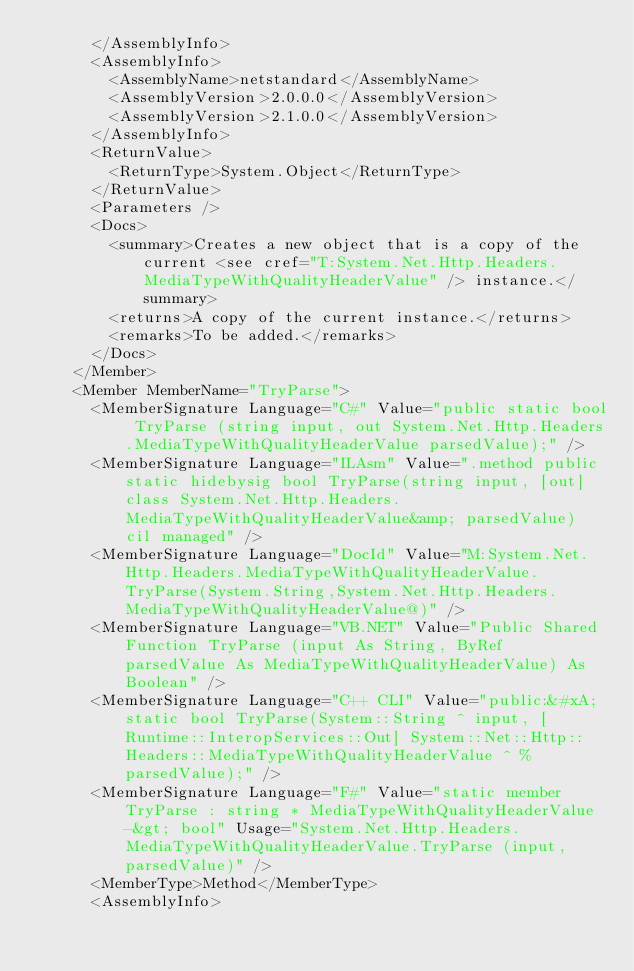Convert code to text. <code><loc_0><loc_0><loc_500><loc_500><_XML_>      </AssemblyInfo>
      <AssemblyInfo>
        <AssemblyName>netstandard</AssemblyName>
        <AssemblyVersion>2.0.0.0</AssemblyVersion>
        <AssemblyVersion>2.1.0.0</AssemblyVersion>
      </AssemblyInfo>
      <ReturnValue>
        <ReturnType>System.Object</ReturnType>
      </ReturnValue>
      <Parameters />
      <Docs>
        <summary>Creates a new object that is a copy of the current <see cref="T:System.Net.Http.Headers.MediaTypeWithQualityHeaderValue" /> instance.</summary>
        <returns>A copy of the current instance.</returns>
        <remarks>To be added.</remarks>
      </Docs>
    </Member>
    <Member MemberName="TryParse">
      <MemberSignature Language="C#" Value="public static bool TryParse (string input, out System.Net.Http.Headers.MediaTypeWithQualityHeaderValue parsedValue);" />
      <MemberSignature Language="ILAsm" Value=".method public static hidebysig bool TryParse(string input, [out] class System.Net.Http.Headers.MediaTypeWithQualityHeaderValue&amp; parsedValue) cil managed" />
      <MemberSignature Language="DocId" Value="M:System.Net.Http.Headers.MediaTypeWithQualityHeaderValue.TryParse(System.String,System.Net.Http.Headers.MediaTypeWithQualityHeaderValue@)" />
      <MemberSignature Language="VB.NET" Value="Public Shared Function TryParse (input As String, ByRef parsedValue As MediaTypeWithQualityHeaderValue) As Boolean" />
      <MemberSignature Language="C++ CLI" Value="public:&#xA; static bool TryParse(System::String ^ input, [Runtime::InteropServices::Out] System::Net::Http::Headers::MediaTypeWithQualityHeaderValue ^ % parsedValue);" />
      <MemberSignature Language="F#" Value="static member TryParse : string * MediaTypeWithQualityHeaderValue -&gt; bool" Usage="System.Net.Http.Headers.MediaTypeWithQualityHeaderValue.TryParse (input, parsedValue)" />
      <MemberType>Method</MemberType>
      <AssemblyInfo></code> 